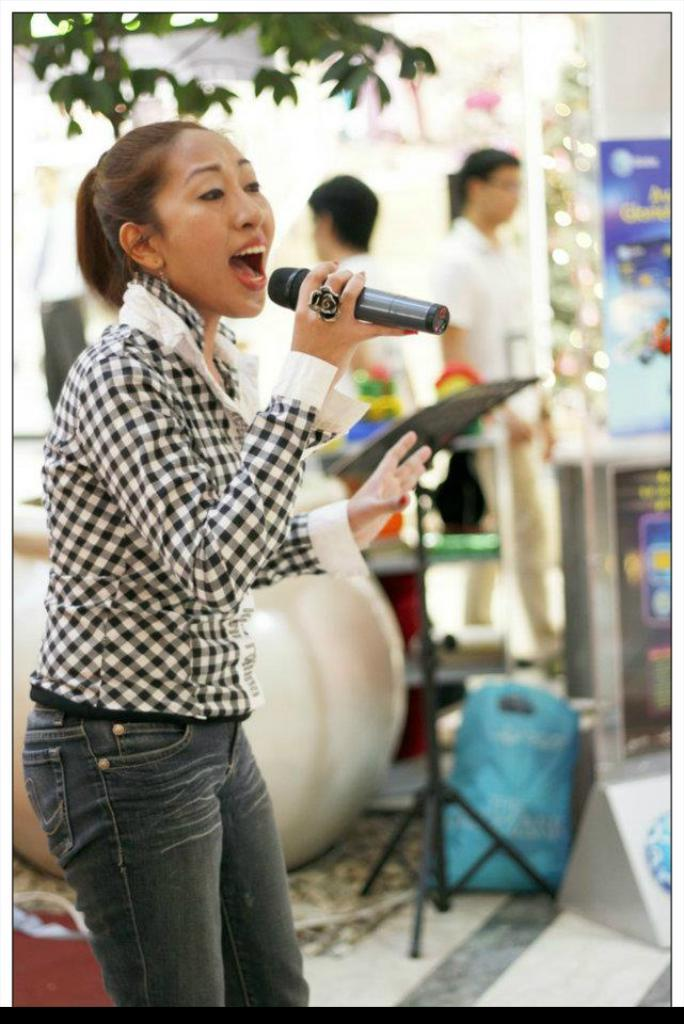Who is the main subject in the picture? There is a girl in the picture. What is the girl doing in the image? The girl is talking. What object is the girl holding in her hand? The girl is holding a microphone in her hand. Can you describe the background of the image? There are people standing in the background of the image, and trees are visible as well. What type of basket is hanging from the tree in the image? There is no basket hanging from a tree in the image. How does the bulb help the girl in the image? There is no bulb present in the image, so it cannot help the girl. 